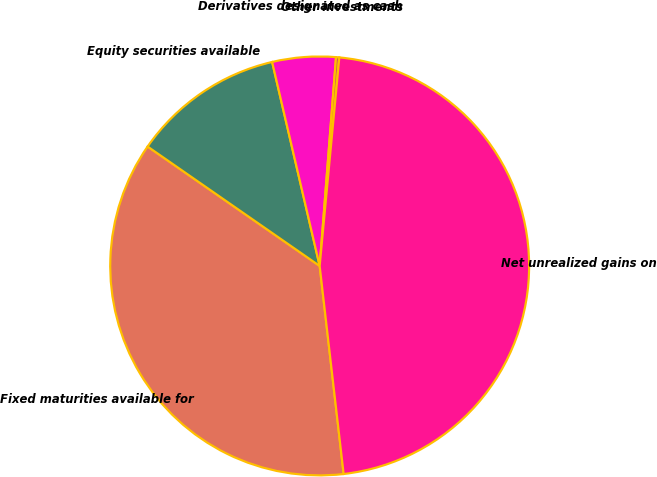Convert chart to OTSL. <chart><loc_0><loc_0><loc_500><loc_500><pie_chart><fcel>Fixed maturities available for<fcel>Equity securities available<fcel>Derivatives designated as cash<fcel>Other investments<fcel>Net unrealized gains on<nl><fcel>36.48%<fcel>11.7%<fcel>4.89%<fcel>0.25%<fcel>46.68%<nl></chart> 